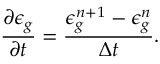<formula> <loc_0><loc_0><loc_500><loc_500>\frac { \partial \epsilon _ { g } } { \partial t } = \frac { \epsilon _ { g } ^ { n + 1 } - \epsilon _ { g } ^ { n } } { \Delta t } .</formula> 